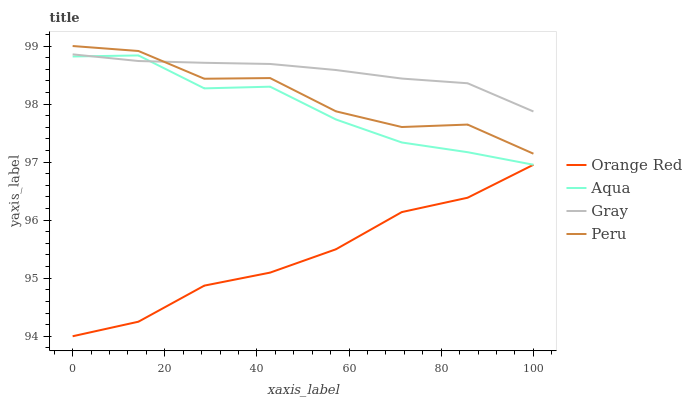Does Orange Red have the minimum area under the curve?
Answer yes or no. Yes. Does Gray have the maximum area under the curve?
Answer yes or no. Yes. Does Aqua have the minimum area under the curve?
Answer yes or no. No. Does Aqua have the maximum area under the curve?
Answer yes or no. No. Is Gray the smoothest?
Answer yes or no. Yes. Is Peru the roughest?
Answer yes or no. Yes. Is Aqua the smoothest?
Answer yes or no. No. Is Aqua the roughest?
Answer yes or no. No. Does Orange Red have the lowest value?
Answer yes or no. Yes. Does Aqua have the lowest value?
Answer yes or no. No. Does Peru have the highest value?
Answer yes or no. Yes. Does Aqua have the highest value?
Answer yes or no. No. Is Orange Red less than Gray?
Answer yes or no. Yes. Is Gray greater than Orange Red?
Answer yes or no. Yes. Does Gray intersect Aqua?
Answer yes or no. Yes. Is Gray less than Aqua?
Answer yes or no. No. Is Gray greater than Aqua?
Answer yes or no. No. Does Orange Red intersect Gray?
Answer yes or no. No. 